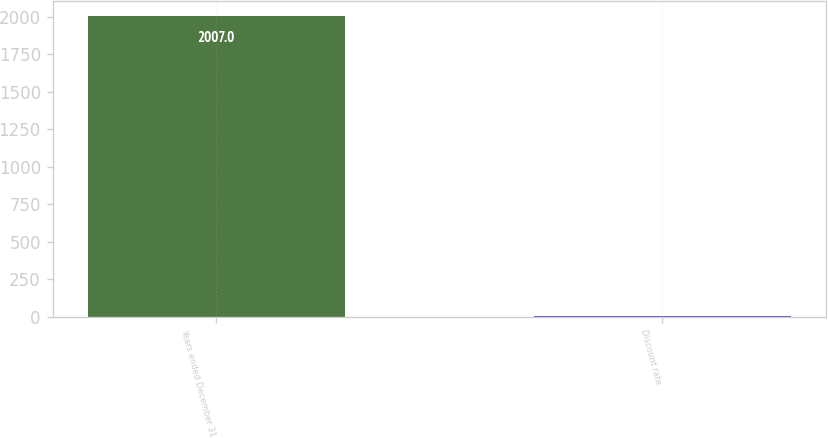Convert chart. <chart><loc_0><loc_0><loc_500><loc_500><bar_chart><fcel>Years ended December 31<fcel>Discount rate<nl><fcel>2007<fcel>5.75<nl></chart> 